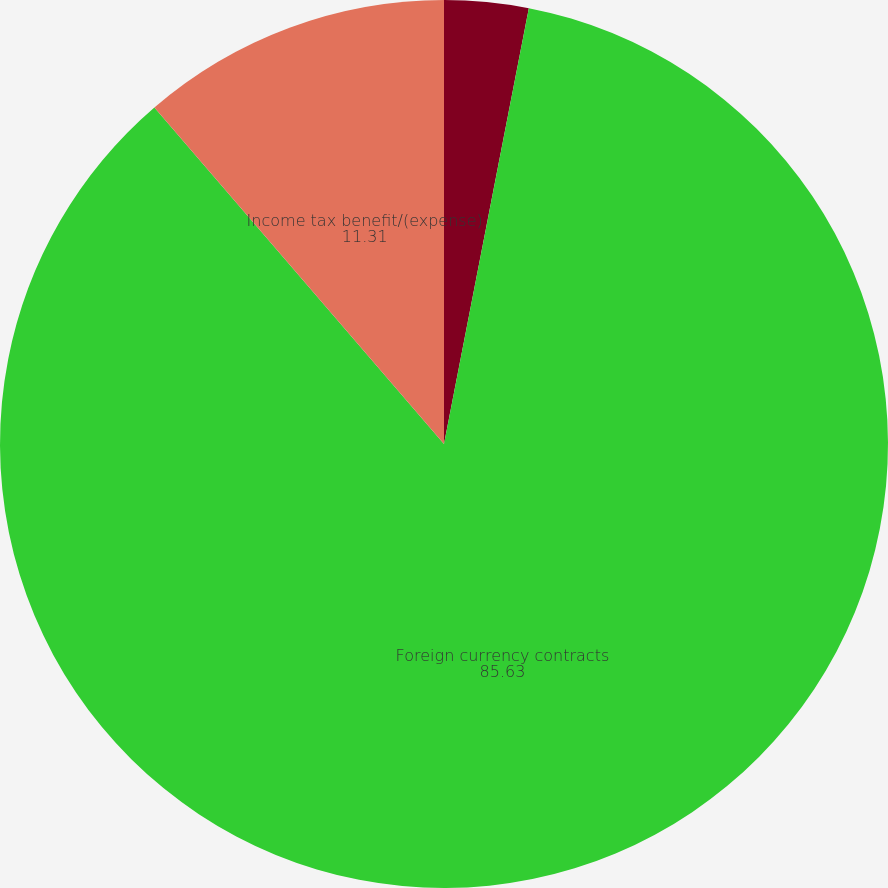<chart> <loc_0><loc_0><loc_500><loc_500><pie_chart><fcel>Interest rate swaps<fcel>Foreign currency contracts<fcel>Income tax benefit/(expense)<nl><fcel>3.06%<fcel>85.63%<fcel>11.31%<nl></chart> 